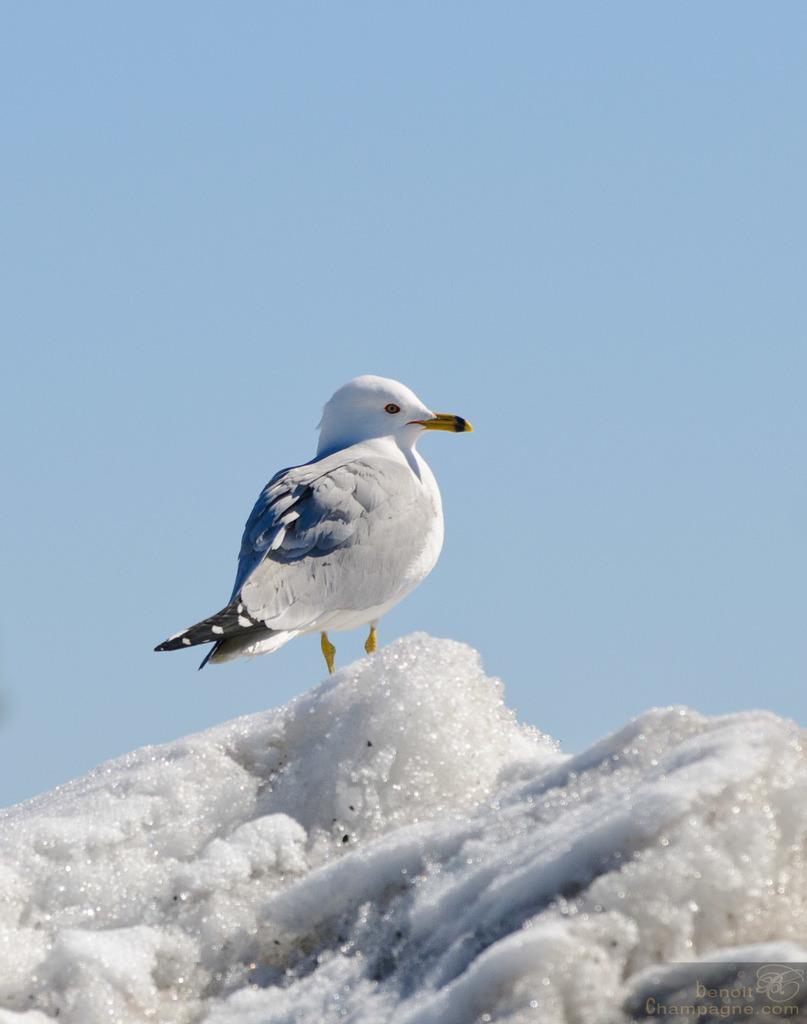Please provide a concise description of this image. In this picture we can see a bird on the snow, at the right bottom of the image we can see a watermark. 